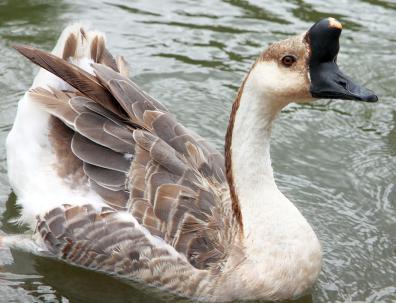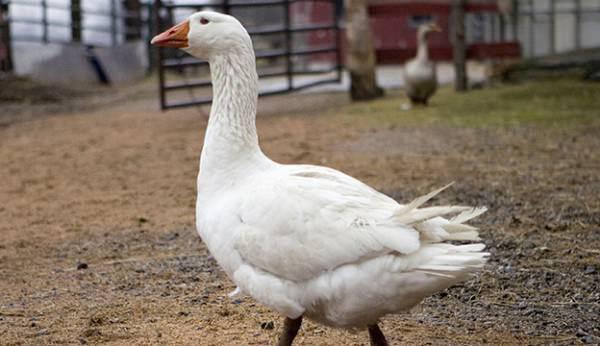The first image is the image on the left, the second image is the image on the right. For the images displayed, is the sentence "there is a single goose with a knob on it's forehead" factually correct? Answer yes or no. Yes. The first image is the image on the left, the second image is the image on the right. For the images displayed, is the sentence "A goose has a horn-like projection above its beak, and the only bird in the foreground of the image on the right is white." factually correct? Answer yes or no. Yes. 